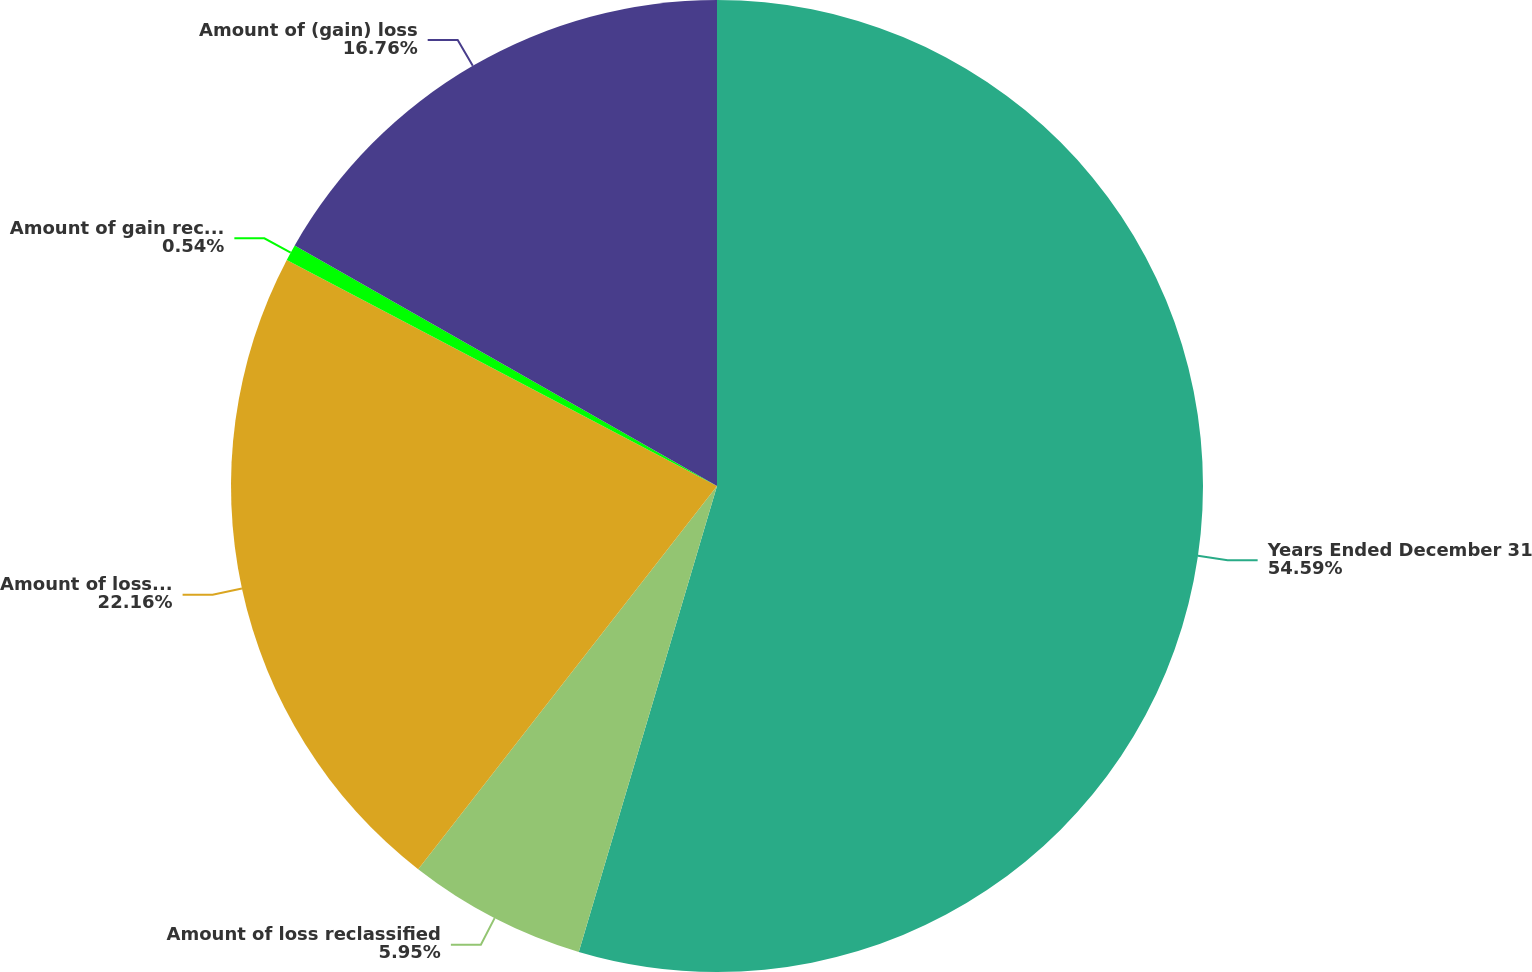Convert chart. <chart><loc_0><loc_0><loc_500><loc_500><pie_chart><fcel>Years Ended December 31<fcel>Amount of loss reclassified<fcel>Amount of loss (gain)<fcel>Amount of gain recognized in<fcel>Amount of (gain) loss<nl><fcel>54.59%<fcel>5.95%<fcel>22.16%<fcel>0.54%<fcel>16.76%<nl></chart> 